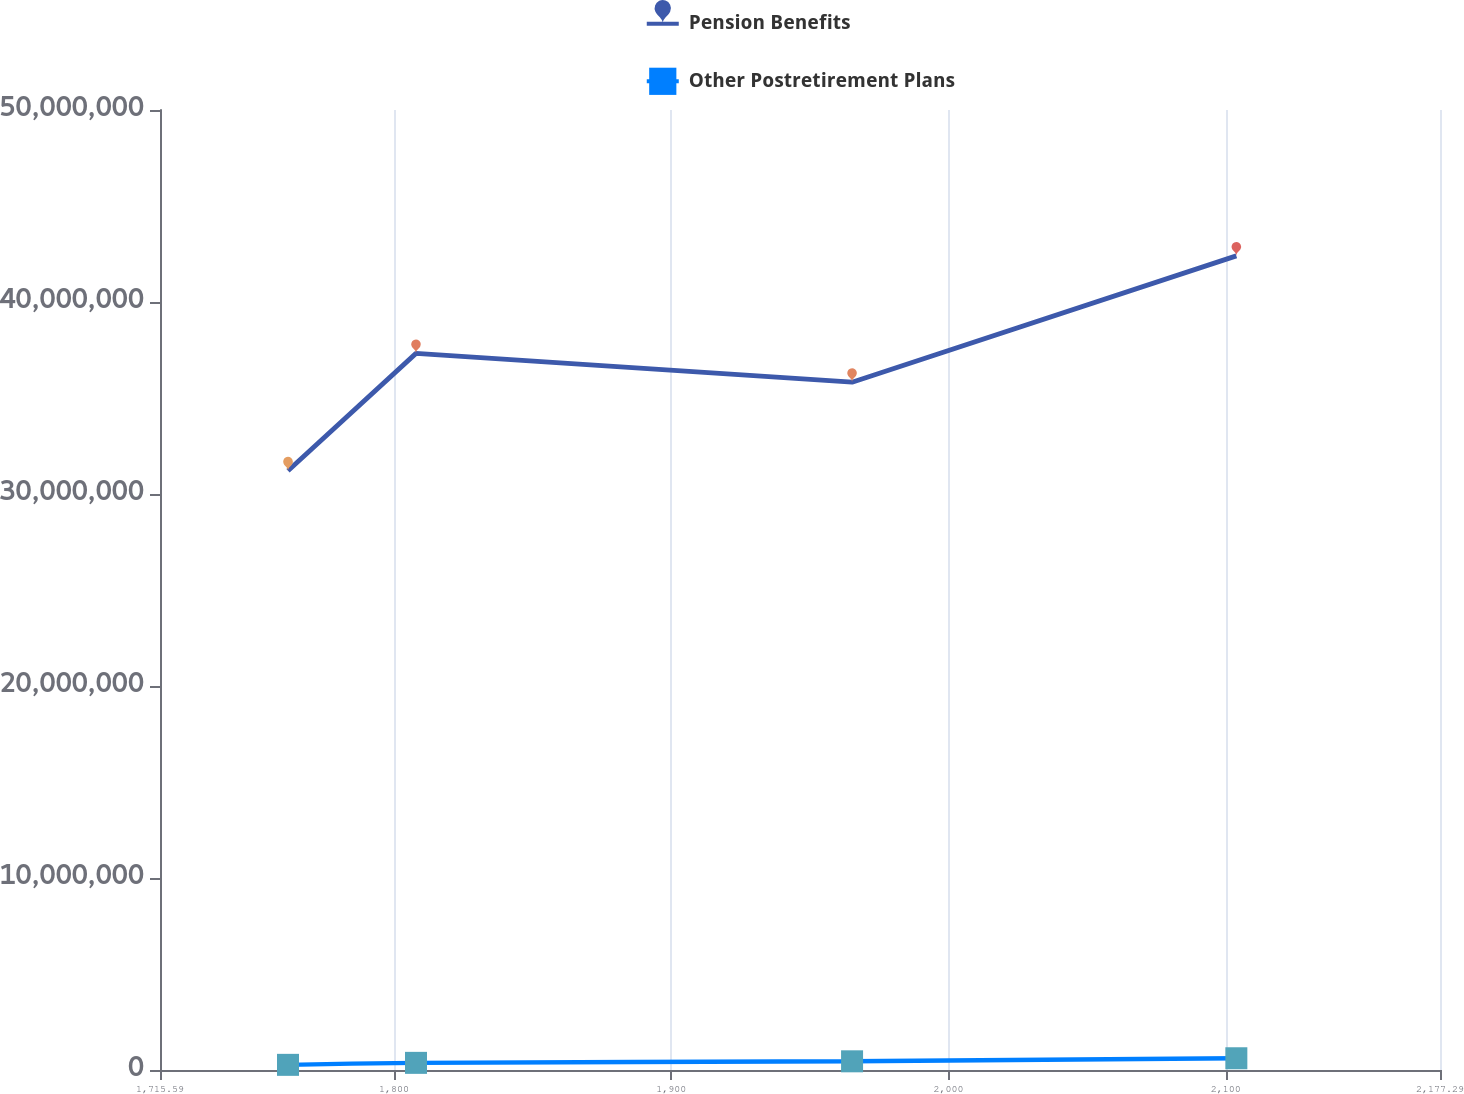<chart> <loc_0><loc_0><loc_500><loc_500><line_chart><ecel><fcel>Pension Benefits<fcel>Other Postretirement Plans<nl><fcel>1761.76<fcel>3.12096e+07<fcel>268194<nl><fcel>1807.93<fcel>3.73233e+07<fcel>372013<nl><fcel>1965.22<fcel>3.58244e+07<fcel>452433<nl><fcel>2103.83<fcel>4.24019e+07<fcel>611755<nl><fcel>2223.46<fcel>4.61985e+07<fcel>649751<nl></chart> 